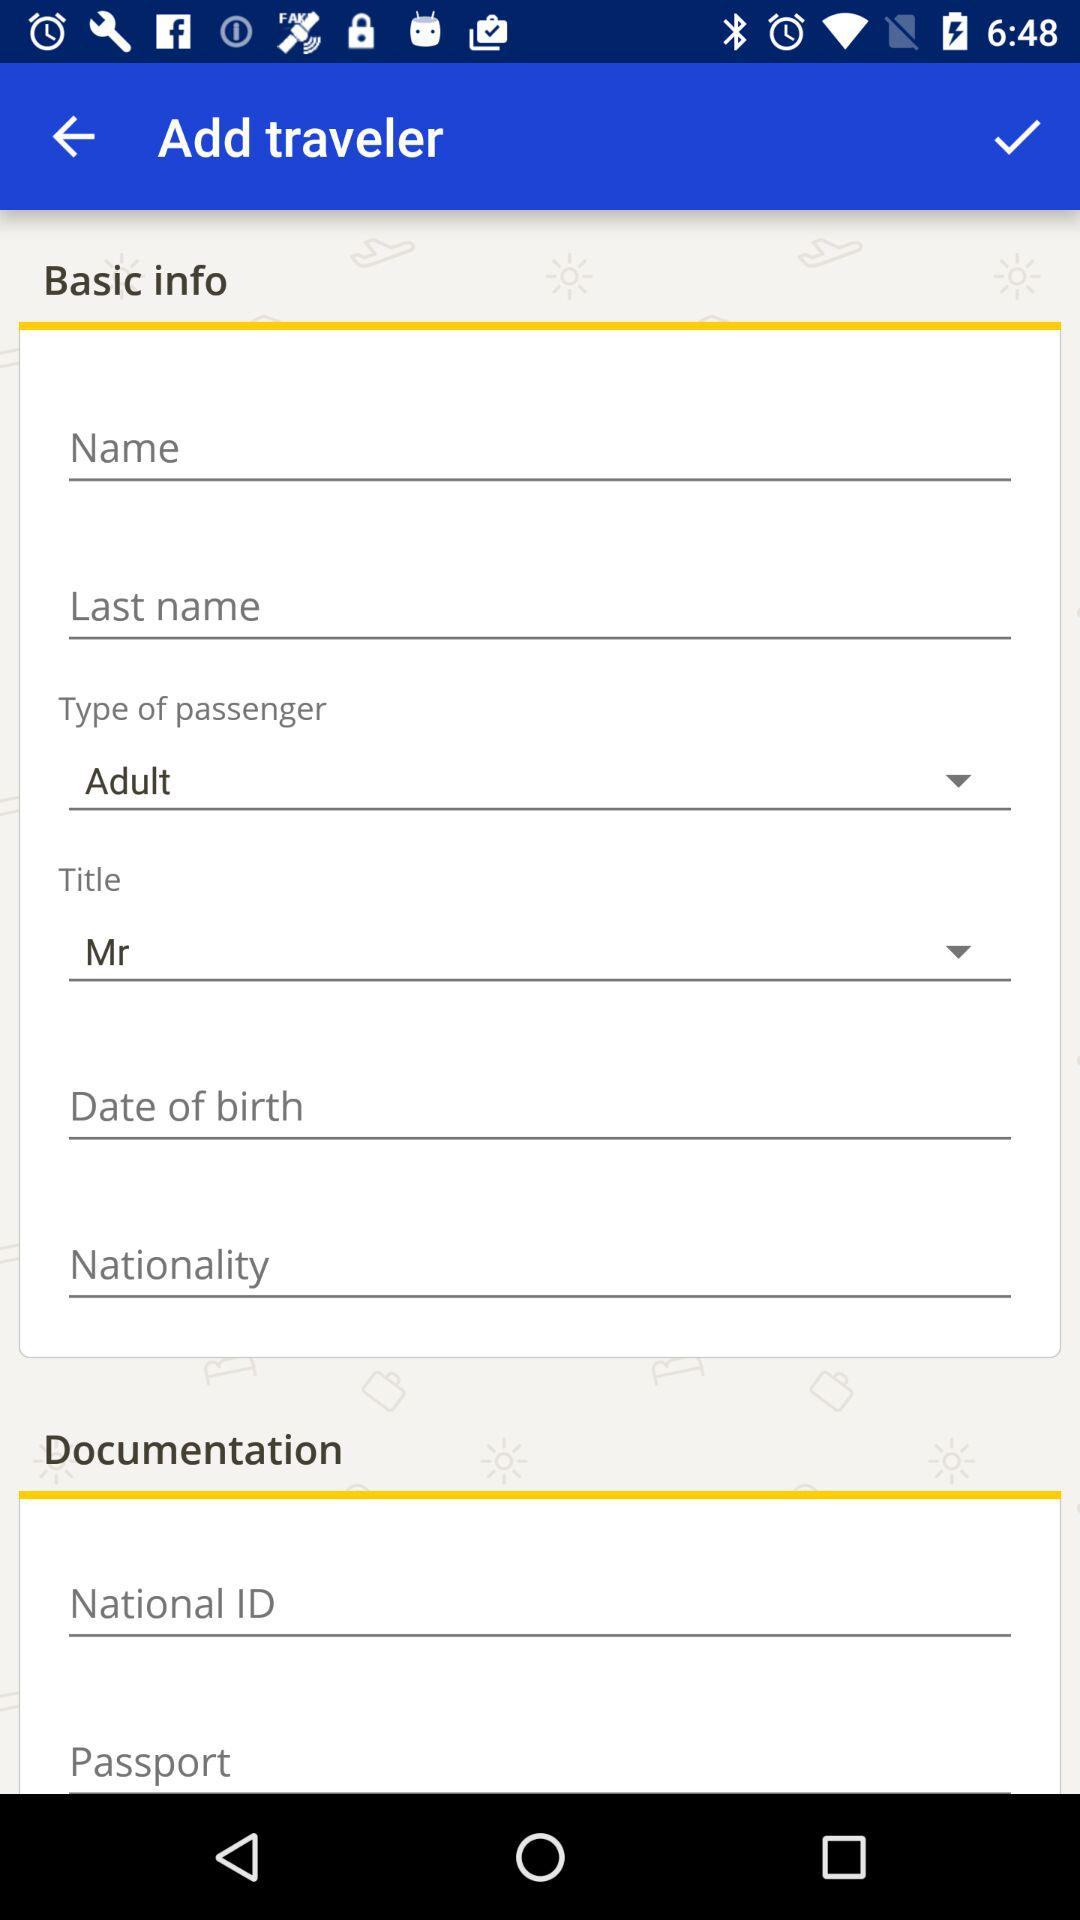What option is selected in "Title"? The selected option in "Title" is "Mr". 